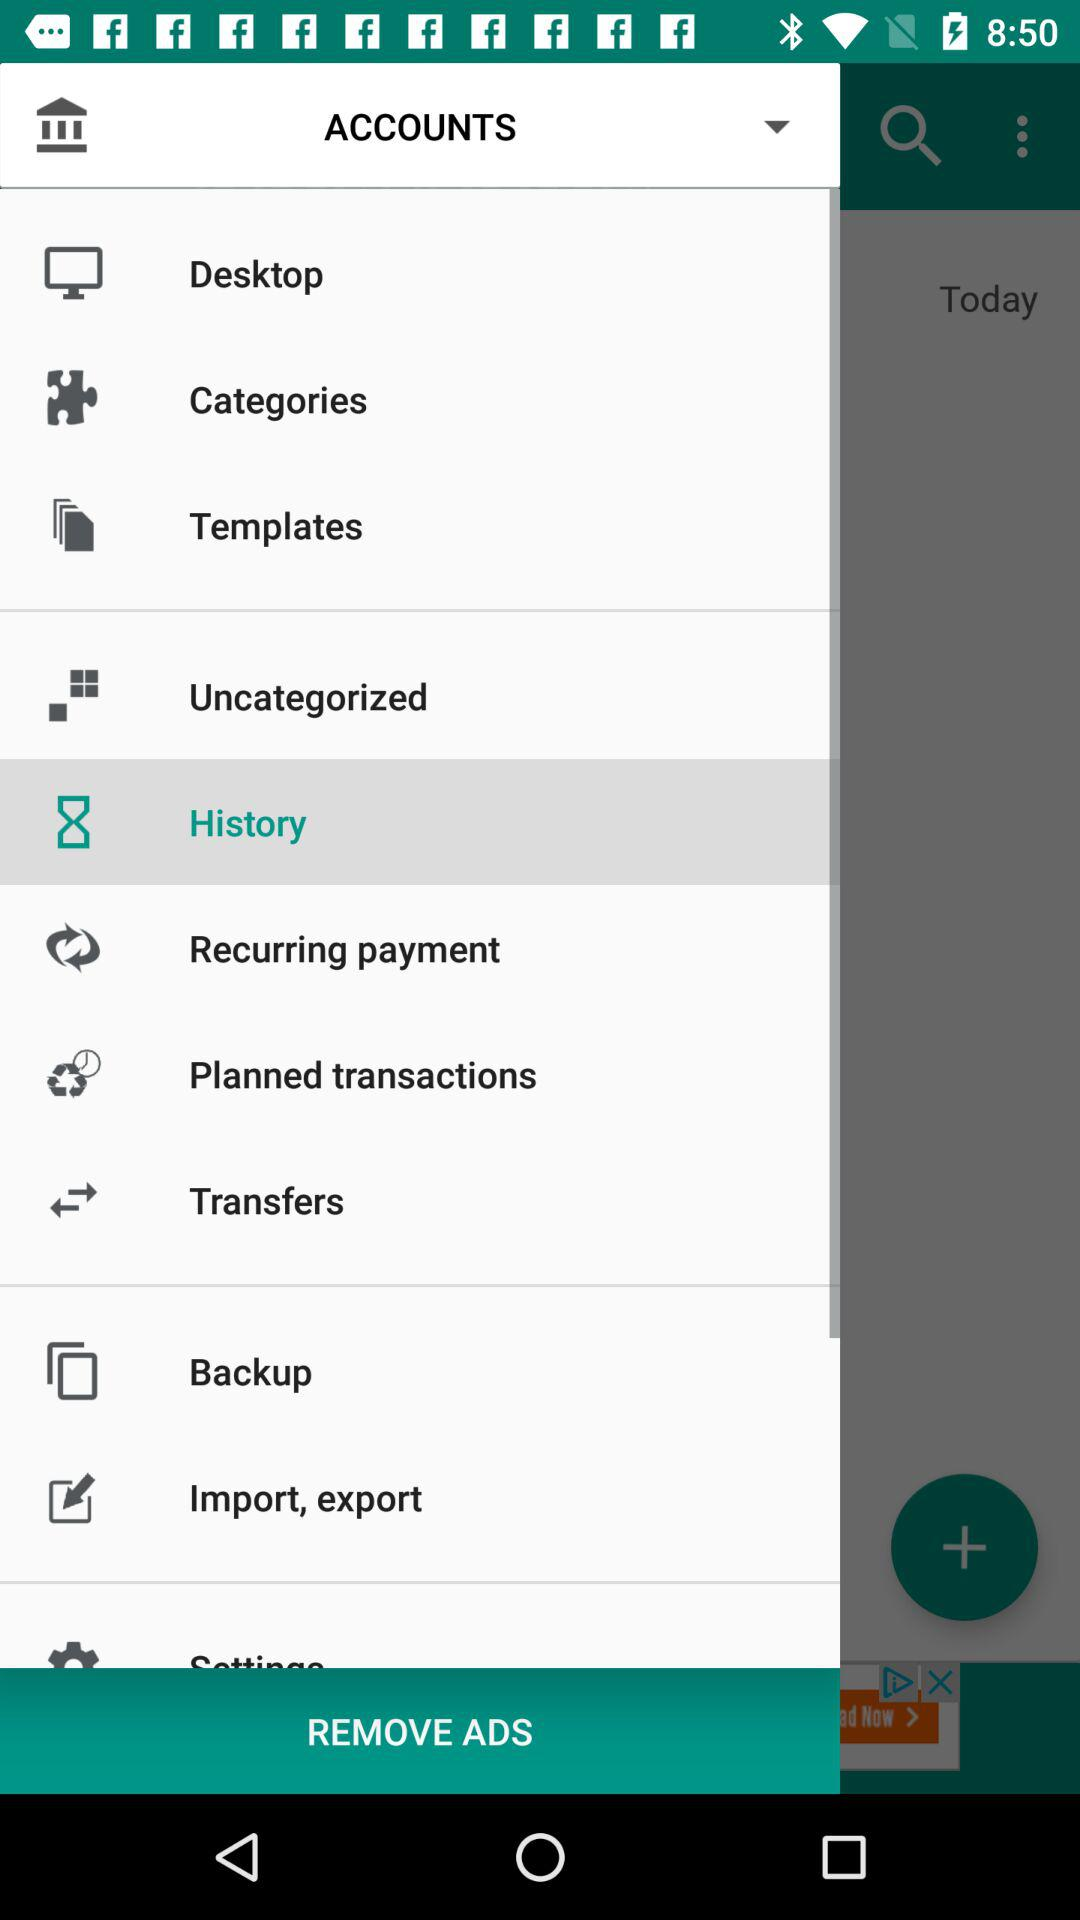Which item is selected in the menu? The item "History" is selected in the menu. 